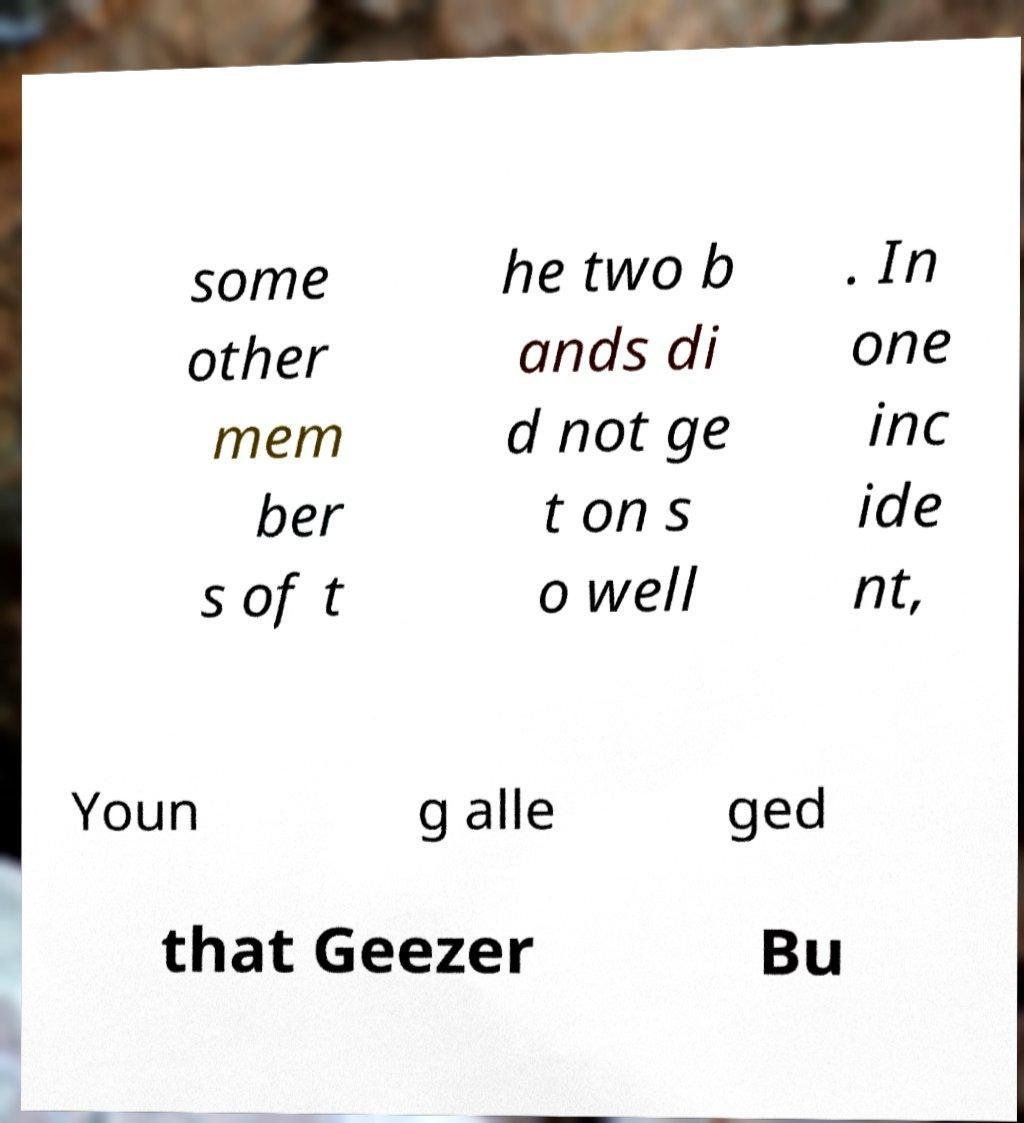Please identify and transcribe the text found in this image. some other mem ber s of t he two b ands di d not ge t on s o well . In one inc ide nt, Youn g alle ged that Geezer Bu 